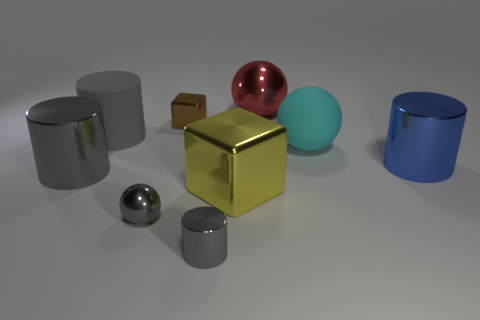Subtract all red cubes. How many gray cylinders are left? 3 Add 1 yellow metal blocks. How many objects exist? 10 Subtract all cubes. How many objects are left? 7 Add 4 large gray cylinders. How many large gray cylinders are left? 6 Add 3 green cubes. How many green cubes exist? 3 Subtract 0 green cubes. How many objects are left? 9 Subtract all brown cubes. Subtract all purple rubber cubes. How many objects are left? 8 